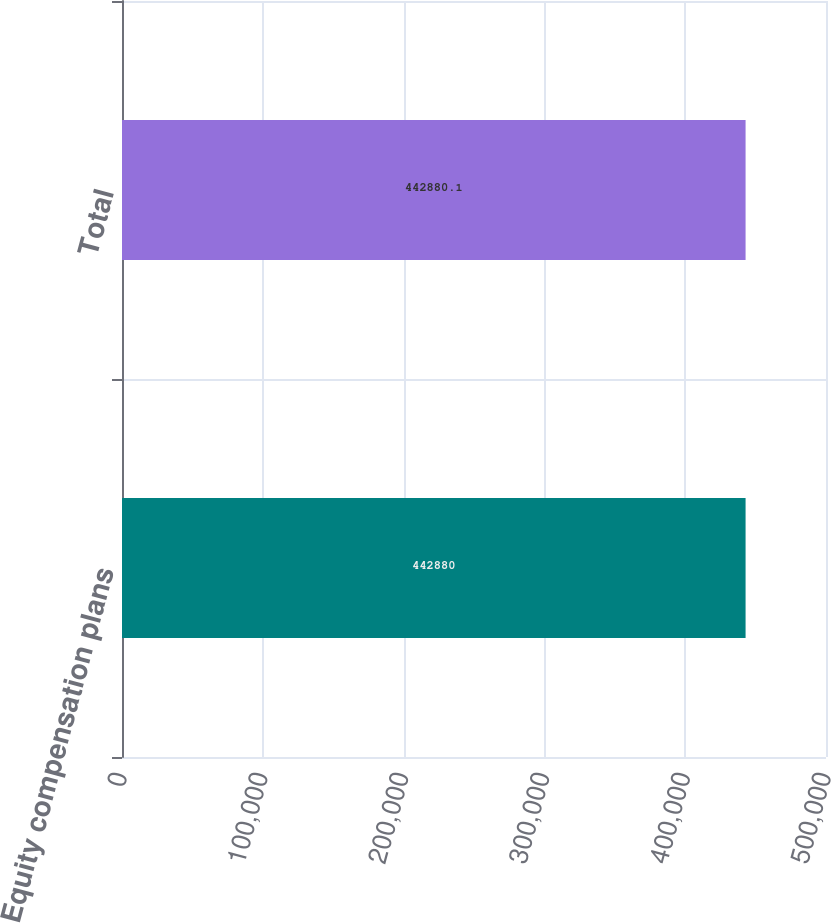<chart> <loc_0><loc_0><loc_500><loc_500><bar_chart><fcel>Equity compensation plans<fcel>Total<nl><fcel>442880<fcel>442880<nl></chart> 